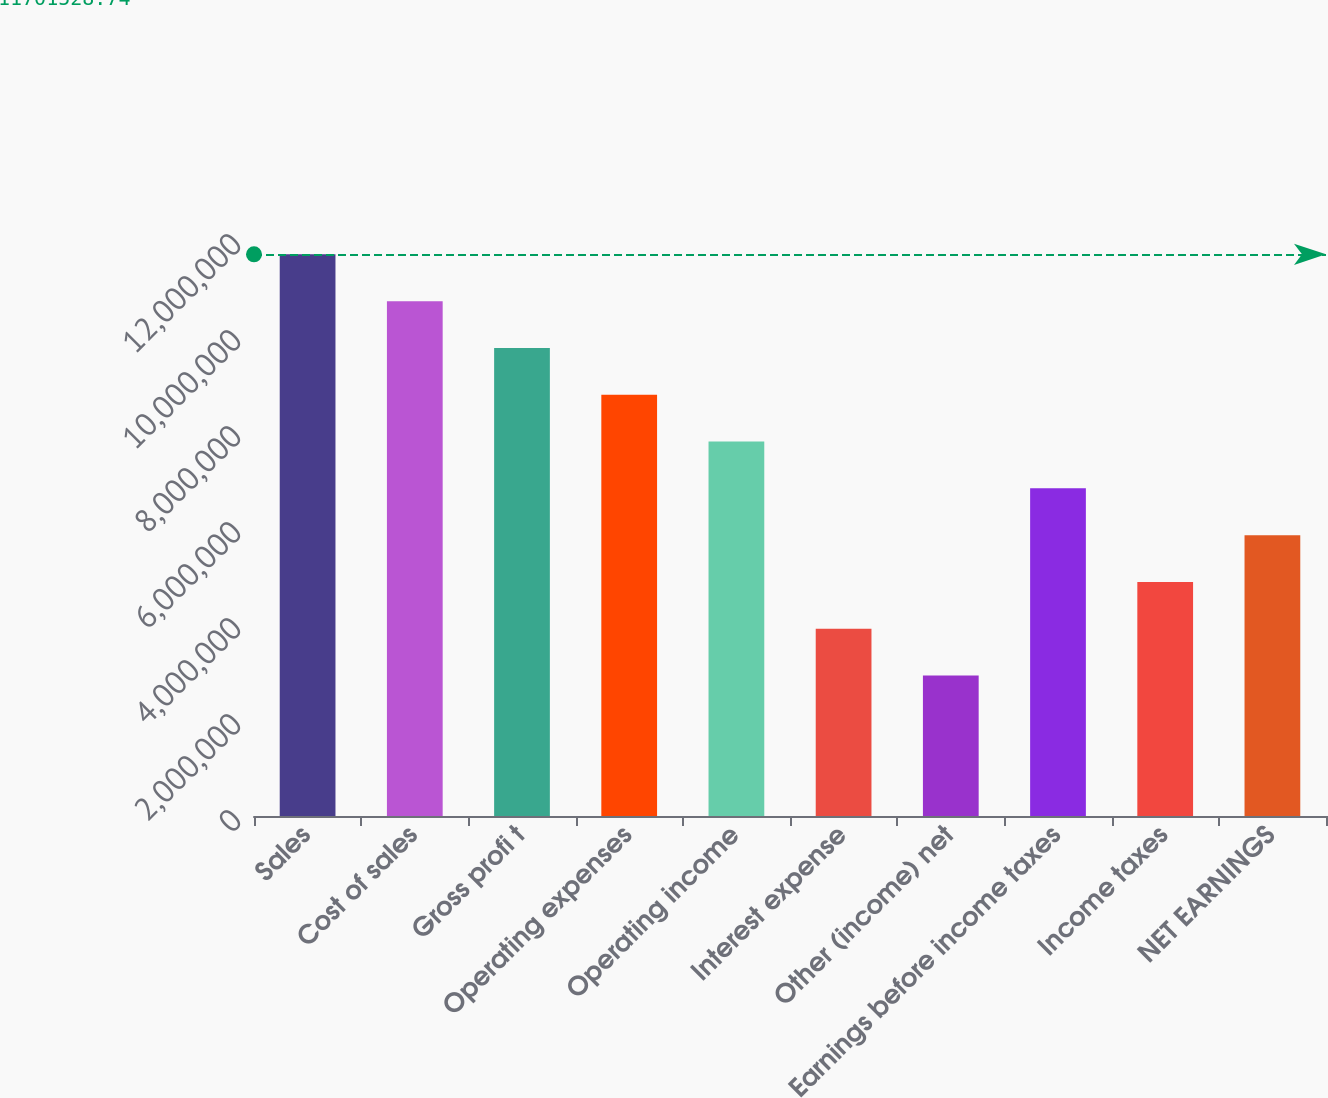Convert chart. <chart><loc_0><loc_0><loc_500><loc_500><bar_chart><fcel>Sales<fcel>Cost of sales<fcel>Gross profi t<fcel>Operating expenses<fcel>Operating income<fcel>Interest expense<fcel>Other (income) net<fcel>Earnings before income taxes<fcel>Income taxes<fcel>NET EARNINGS<nl><fcel>1.17015e+07<fcel>1.07264e+07<fcel>9.75127e+06<fcel>8.77615e+06<fcel>7.80102e+06<fcel>3.90051e+06<fcel>2.92538e+06<fcel>6.82589e+06<fcel>4.87564e+06<fcel>5.85076e+06<nl></chart> 